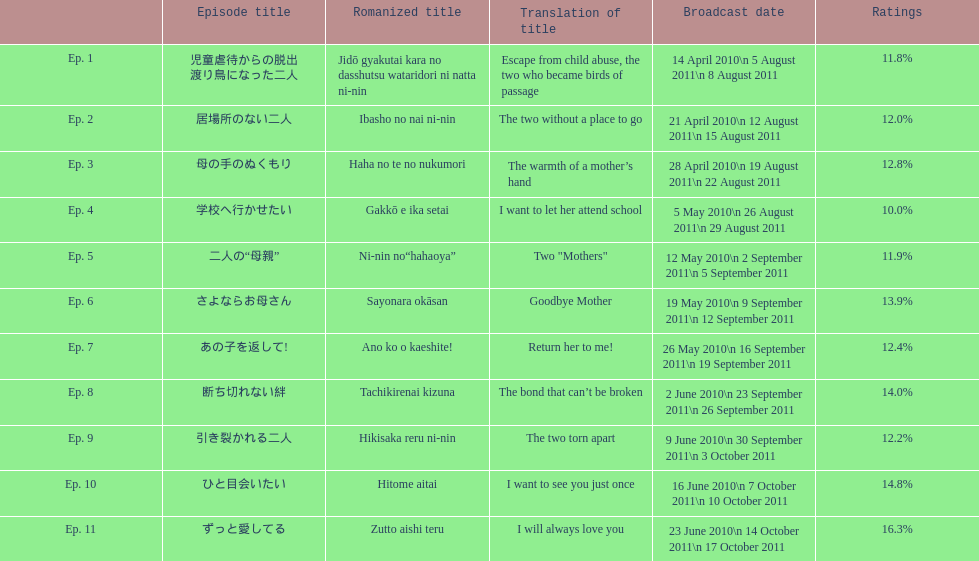Besides the 10th episode, which other episode possesses a 14% rating? Ep. 8. 